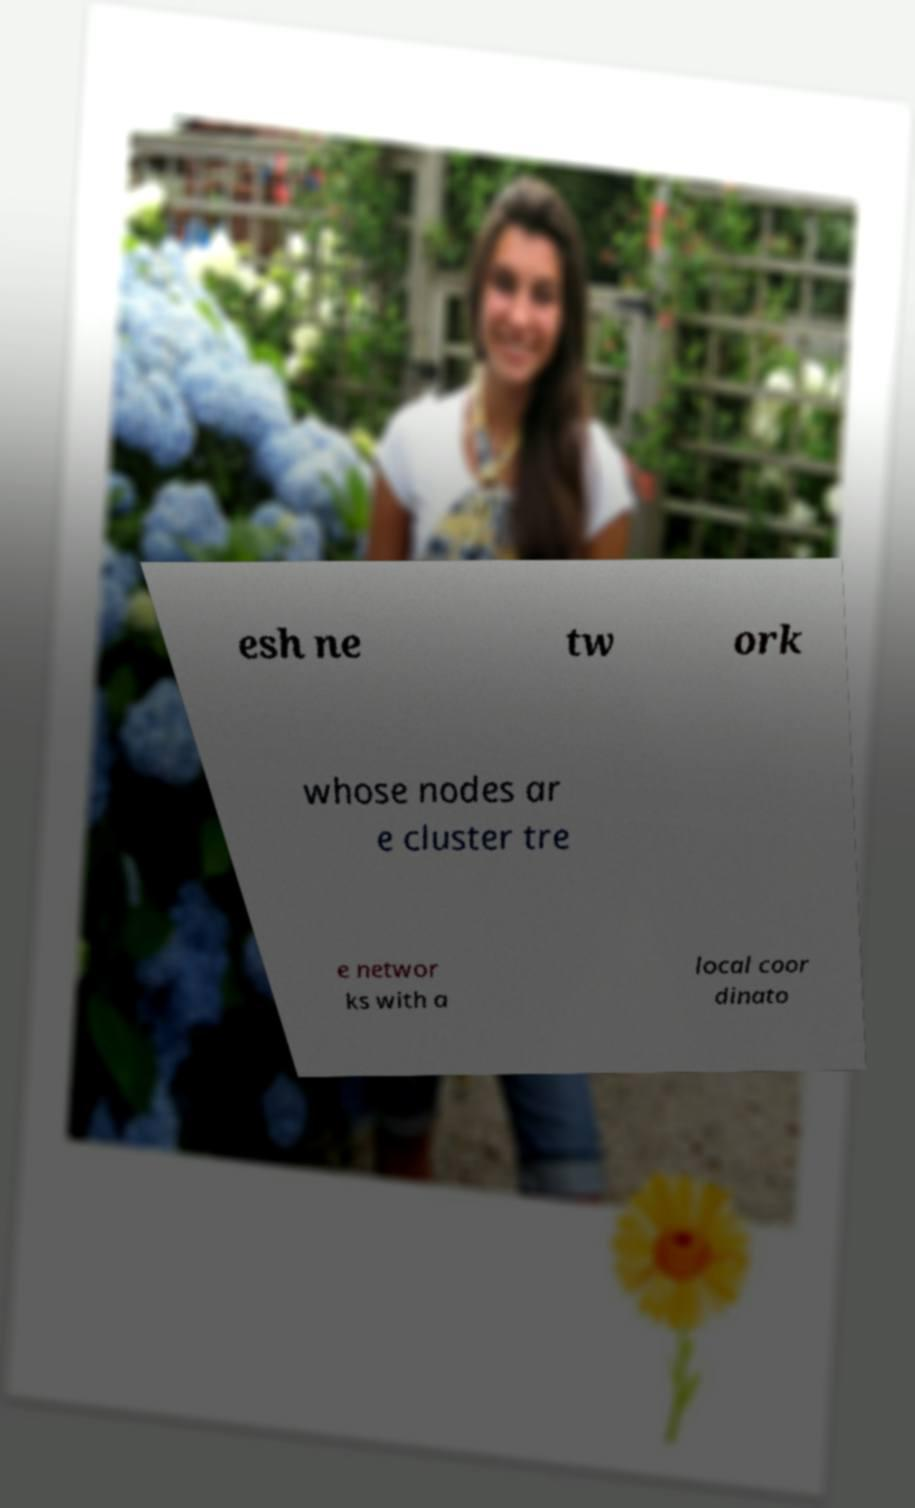What messages or text are displayed in this image? I need them in a readable, typed format. esh ne tw ork whose nodes ar e cluster tre e networ ks with a local coor dinato 